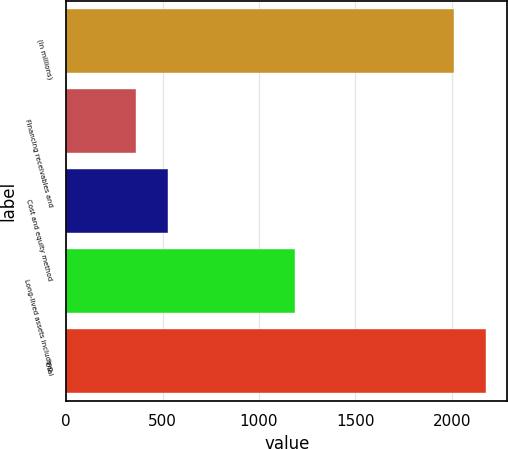Convert chart to OTSL. <chart><loc_0><loc_0><loc_500><loc_500><bar_chart><fcel>(In millions)<fcel>Financing receivables and<fcel>Cost and equity method<fcel>Long-lived assets including<fcel>Total<nl><fcel>2013<fcel>361<fcel>528.2<fcel>1188<fcel>2180.2<nl></chart> 